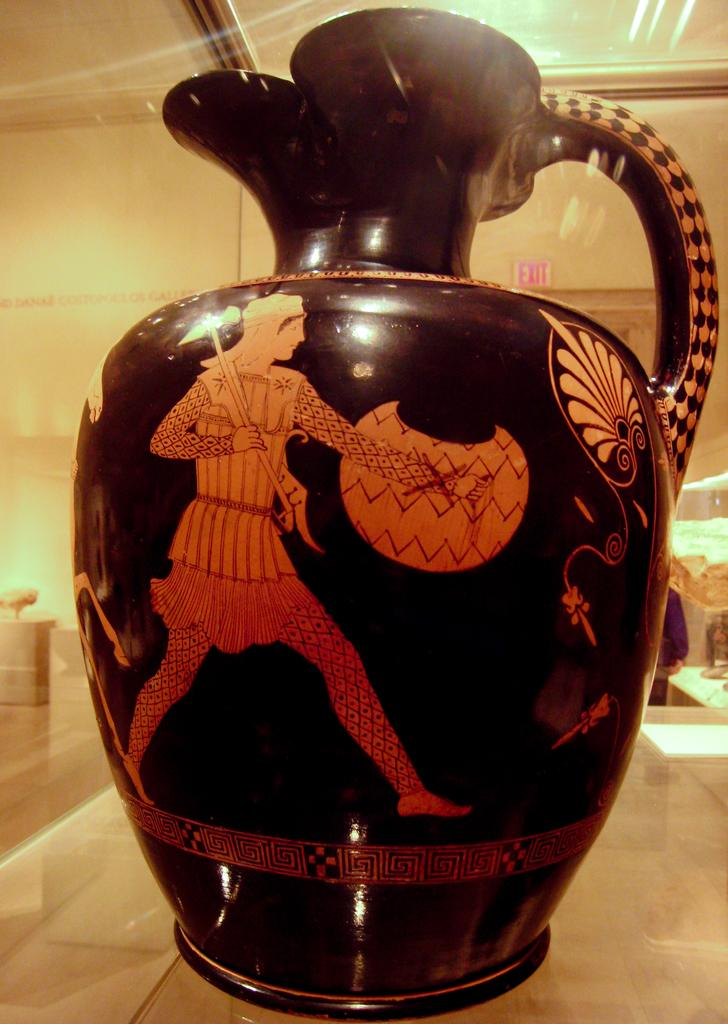What object is the main focus of the image? There is a pot in the image. What can be seen in the background of the image? There is a wall in the background of the image. Where is the nearest store to the pot in the image? There is no information about a store in the image, as it only features a pot and a wall in the background. 